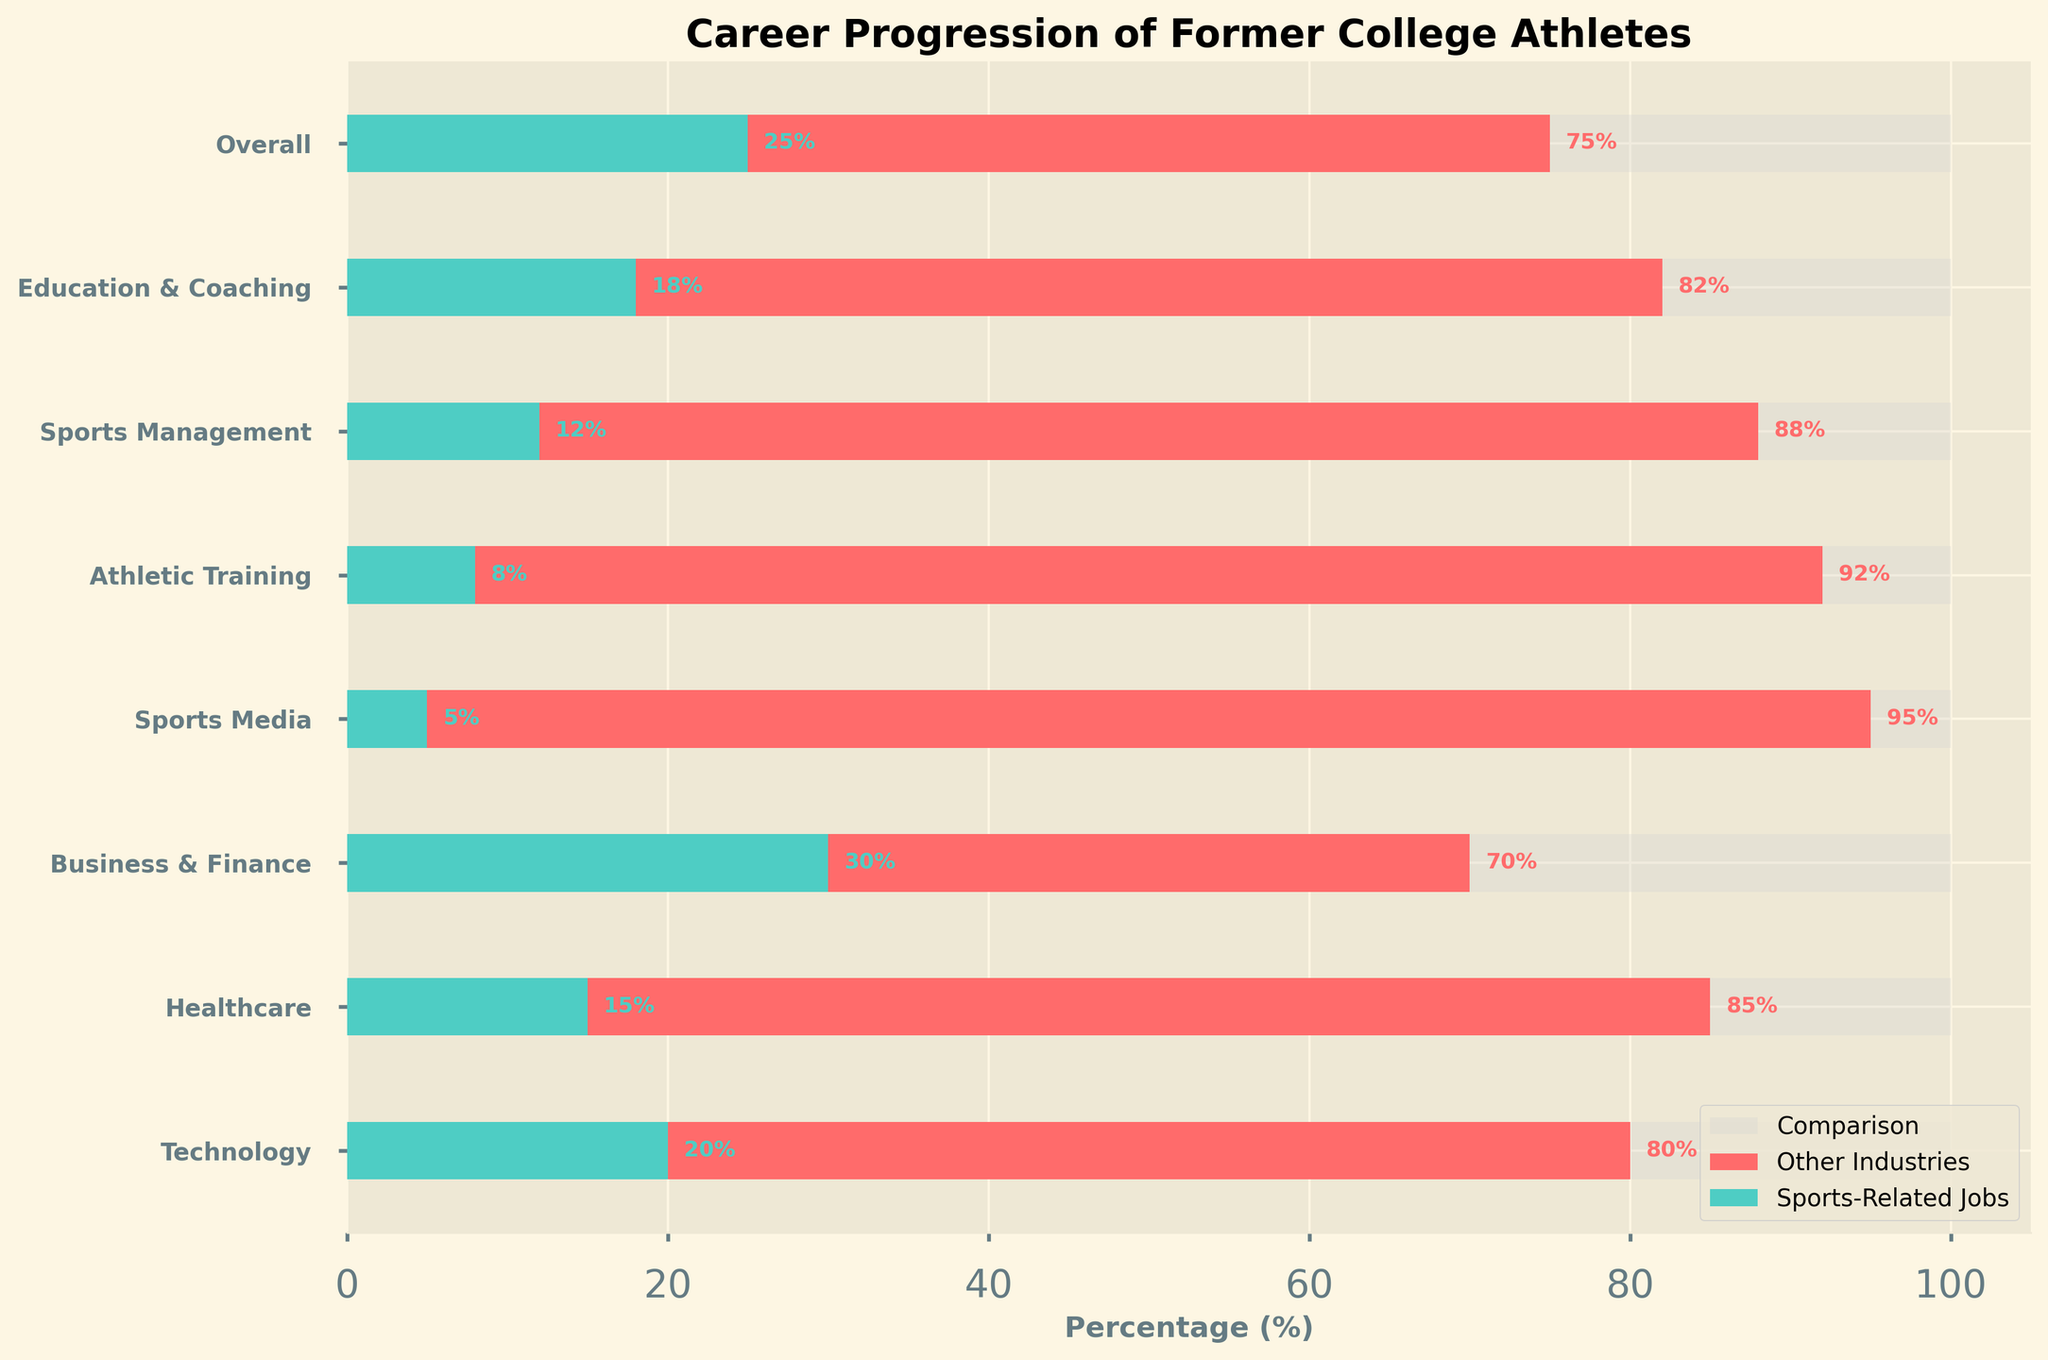What is the title of the chart? The title of the chart is at the top and states "Career Progression of Former College Athletes".
Answer: Career Progression of Former College Athletes Which category has the highest percentage of former athletes in sports-related jobs? By looking at the green bars representing sports-related jobs, "Business & Finance" has the highest percentage at 30%.
Answer: Business & Finance What percentage of former athletes in "Sports Media" are in other industries? The red bar next to "Sports Media" shows the percentage of former athletes in other industries, which is 95%.
Answer: 95% What is the total percentage represented on the chart for each category? The background light grey bar represents the total percentage of 100% for each category.
Answer: 100% How does the percentage of former athletes in sports-related jobs in "Technology" compare to "Athletic Training"? The green bar for "Technology" shows 20% while "Athletic Training" shows 8%. Thus, "Technology" has a higher percentage of former athletes in sports-related jobs compared to "Athletic Training".
Answer: Technology has 12% more Which category has the least percentage of former athletes in sports-related jobs? The green bars represent sports-related jobs, and "Sports Media" has the smallest bar at 5%.
Answer: Sports Media What is the percentage difference in former athletes in other industries between "Business & Finance" and "Healthcare"? The red bar for "Business & Finance" shows 70% and for "Healthcare" it shows 85%. The difference is 85 - 70 = 15%.
Answer: 15% How many categories have more than 80% of former athletes in other industries? The categories with red bars extending beyond 80% are "Education & Coaching", "Sports Management", "Athletic Training", "Sports Media", and "Healthcare". There are 5 such categories.
Answer: 5 What is the combined percentage of former athletes in sports-related jobs for "Education & Coaching" and "Sports Management"? The green bars for "Education & Coaching" and "Sports Management" show 18% and 12% respectively. Combined, this is 18 + 12 = 30%.
Answer: 30% Is the proportion of athletes working in other industries in "Healthcare" higher or lower than the overall percentage? The red bar for "Healthcare" shows 85%, and for the overall category, it shows 75%. Therefore, "Healthcare" has a higher proportion in other industries compared to the overall percentage.
Answer: Higher 